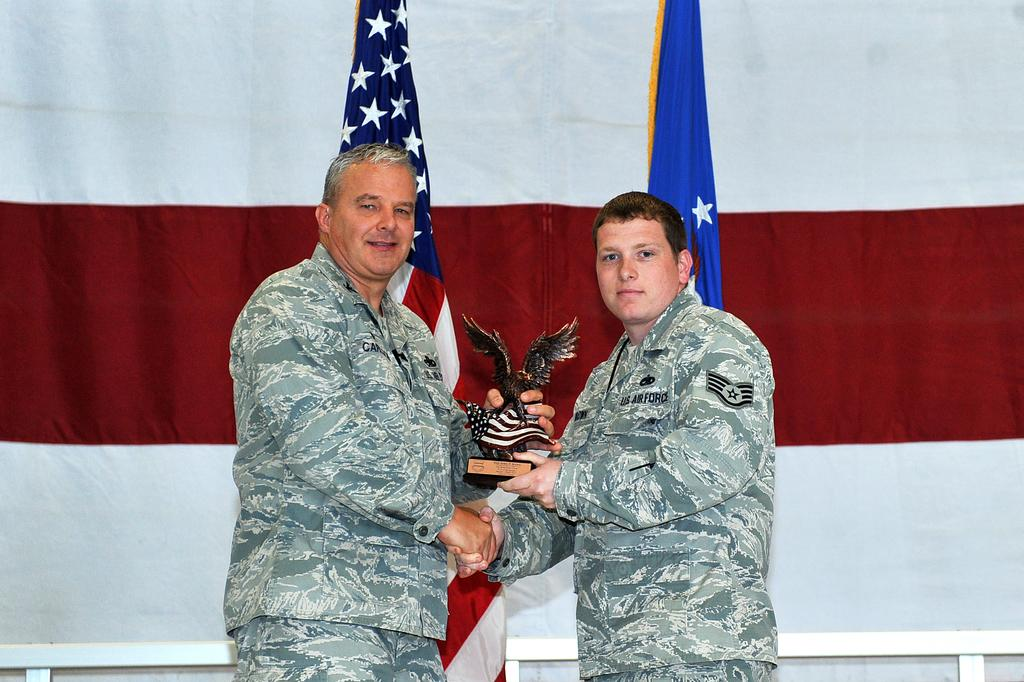How many people are present in the image? There are two people in the image. What are the people doing in the image? The people are standing and holding a statue. What can be seen in the background of the image? There are flags and a white object in the background of the image. Additionally, there is colorful cloth in the background. What type of wax can be seen melting on the statue in the image? There is no wax present in the image, nor is there any indication of melting wax on the statue. 